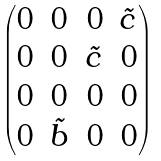Convert formula to latex. <formula><loc_0><loc_0><loc_500><loc_500>\begin{pmatrix} 0 & 0 & 0 & \tilde { c } \\ 0 & 0 & \tilde { c } & 0 \\ 0 & 0 & 0 & 0 \\ 0 & \tilde { b } & 0 & 0 \end{pmatrix}</formula> 